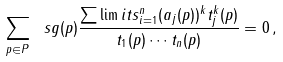<formula> <loc_0><loc_0><loc_500><loc_500>\sum _ { p \in P } \ s g ( p ) \frac { \sum \lim i t s _ { i = 1 } ^ { n } ( a _ { j } ( p ) ) ^ { k } t _ { j } ^ { k } ( p ) } { t _ { 1 } ( p ) \cdots t _ { n } ( p ) } = 0 \, ,</formula> 